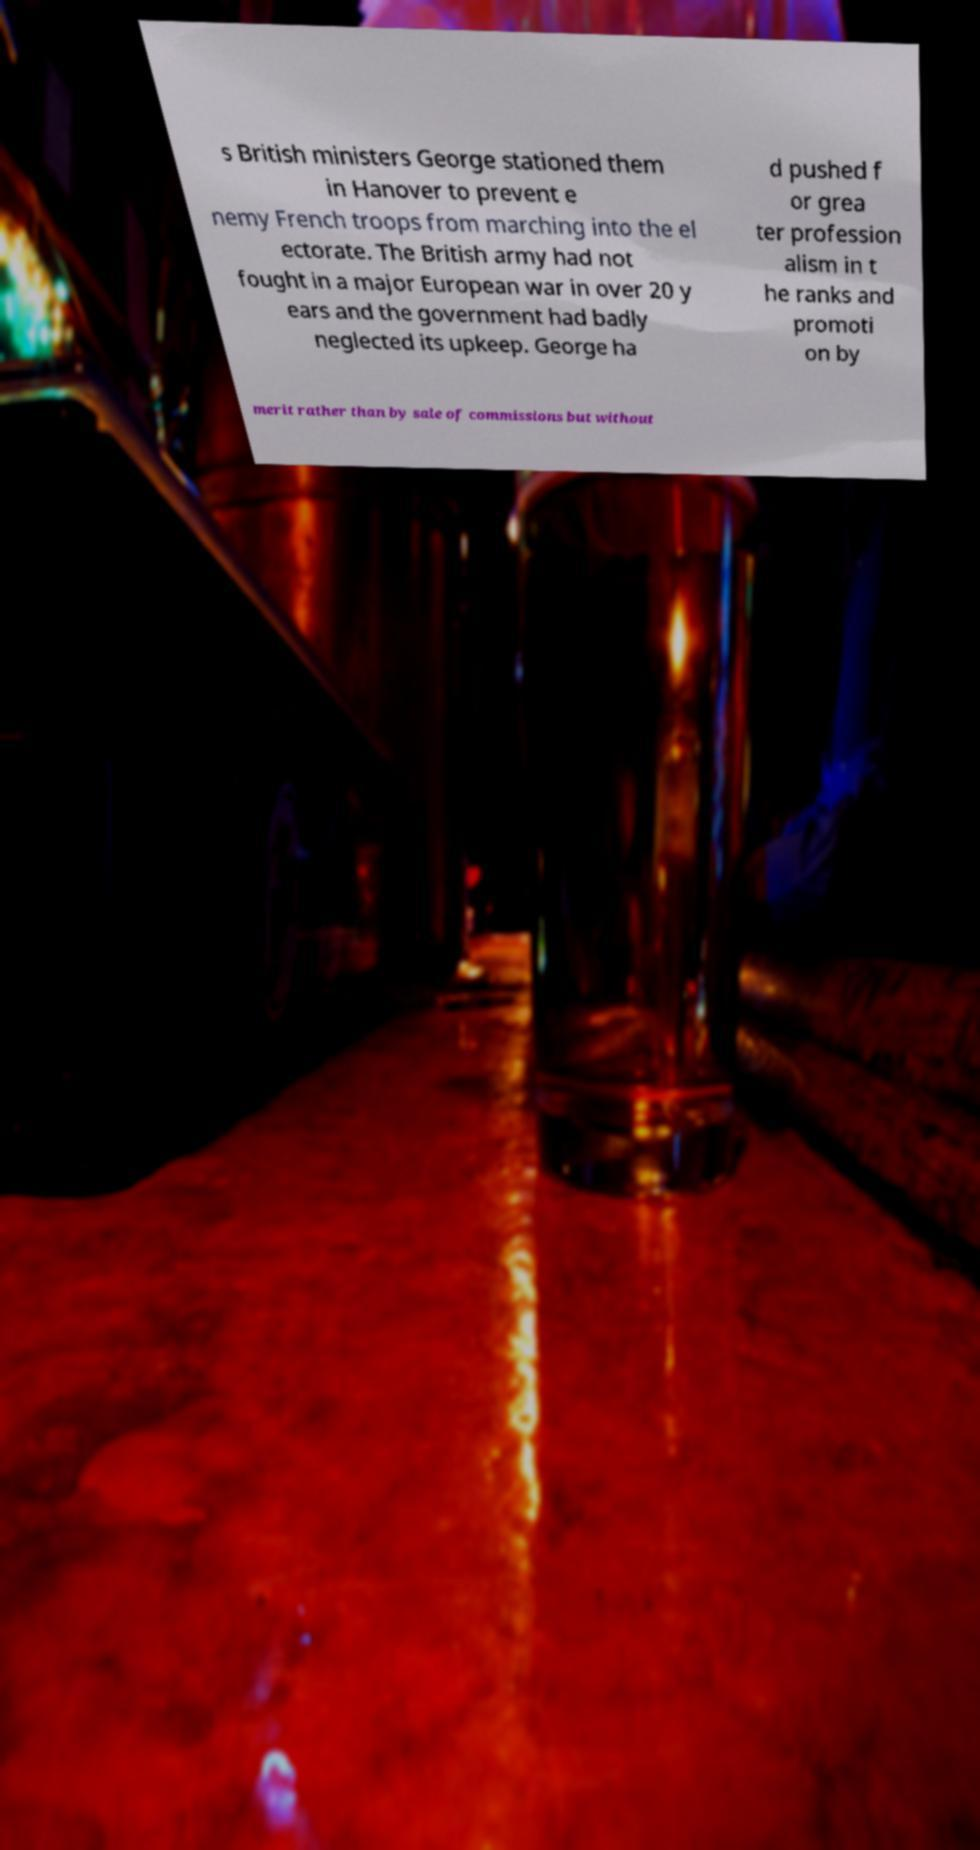There's text embedded in this image that I need extracted. Can you transcribe it verbatim? s British ministers George stationed them in Hanover to prevent e nemy French troops from marching into the el ectorate. The British army had not fought in a major European war in over 20 y ears and the government had badly neglected its upkeep. George ha d pushed f or grea ter profession alism in t he ranks and promoti on by merit rather than by sale of commissions but without 